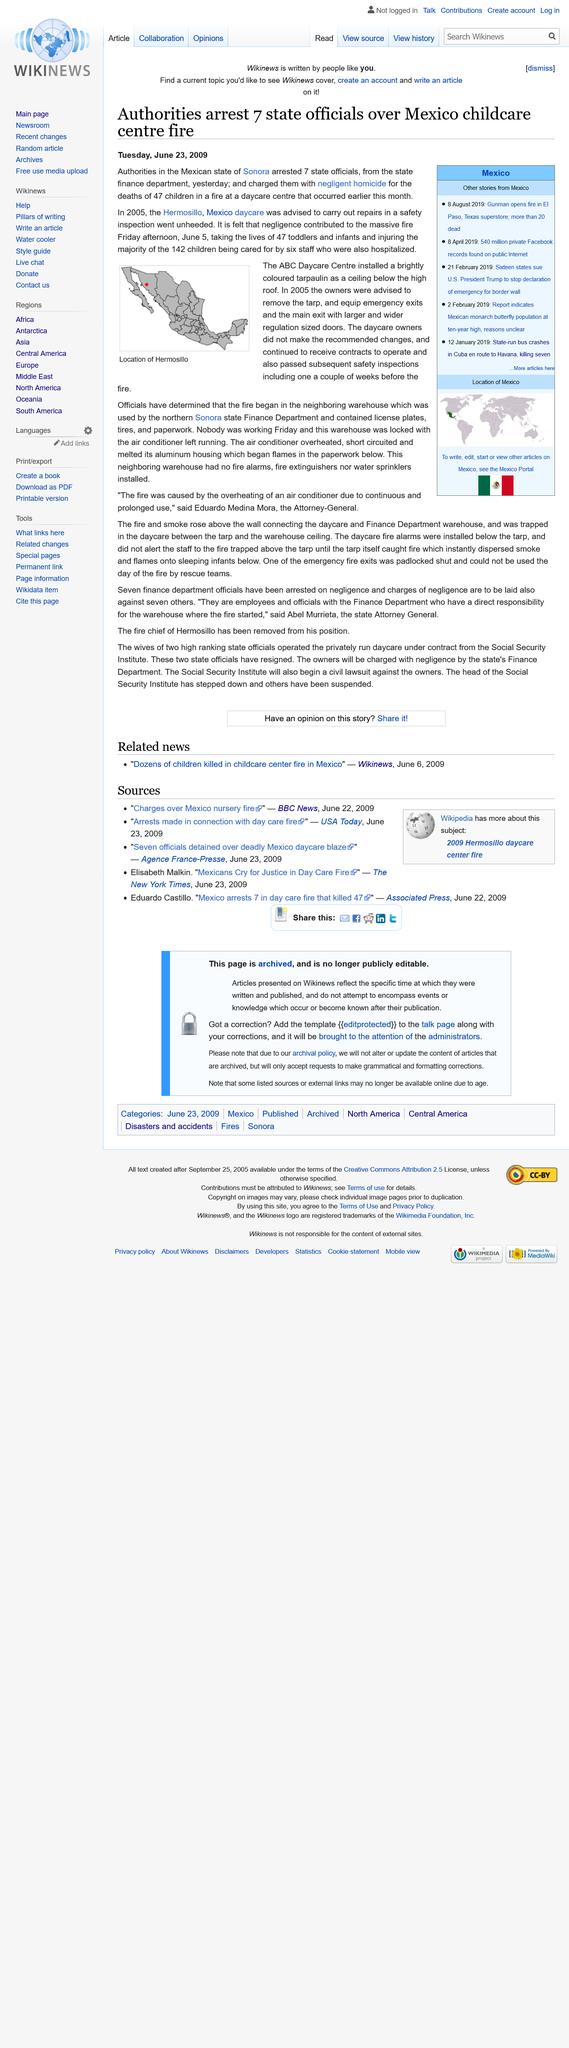Give some essential details in this illustration. In 2005, the owners were advised to remove a tarp used as a ceiling, and 47 children were tragically killed in the fire that this contributed towards. Seventeen state officials have been charged with negligent homicide. On the daycare burned down, it was the ABC Daycare Centre where it took place. 